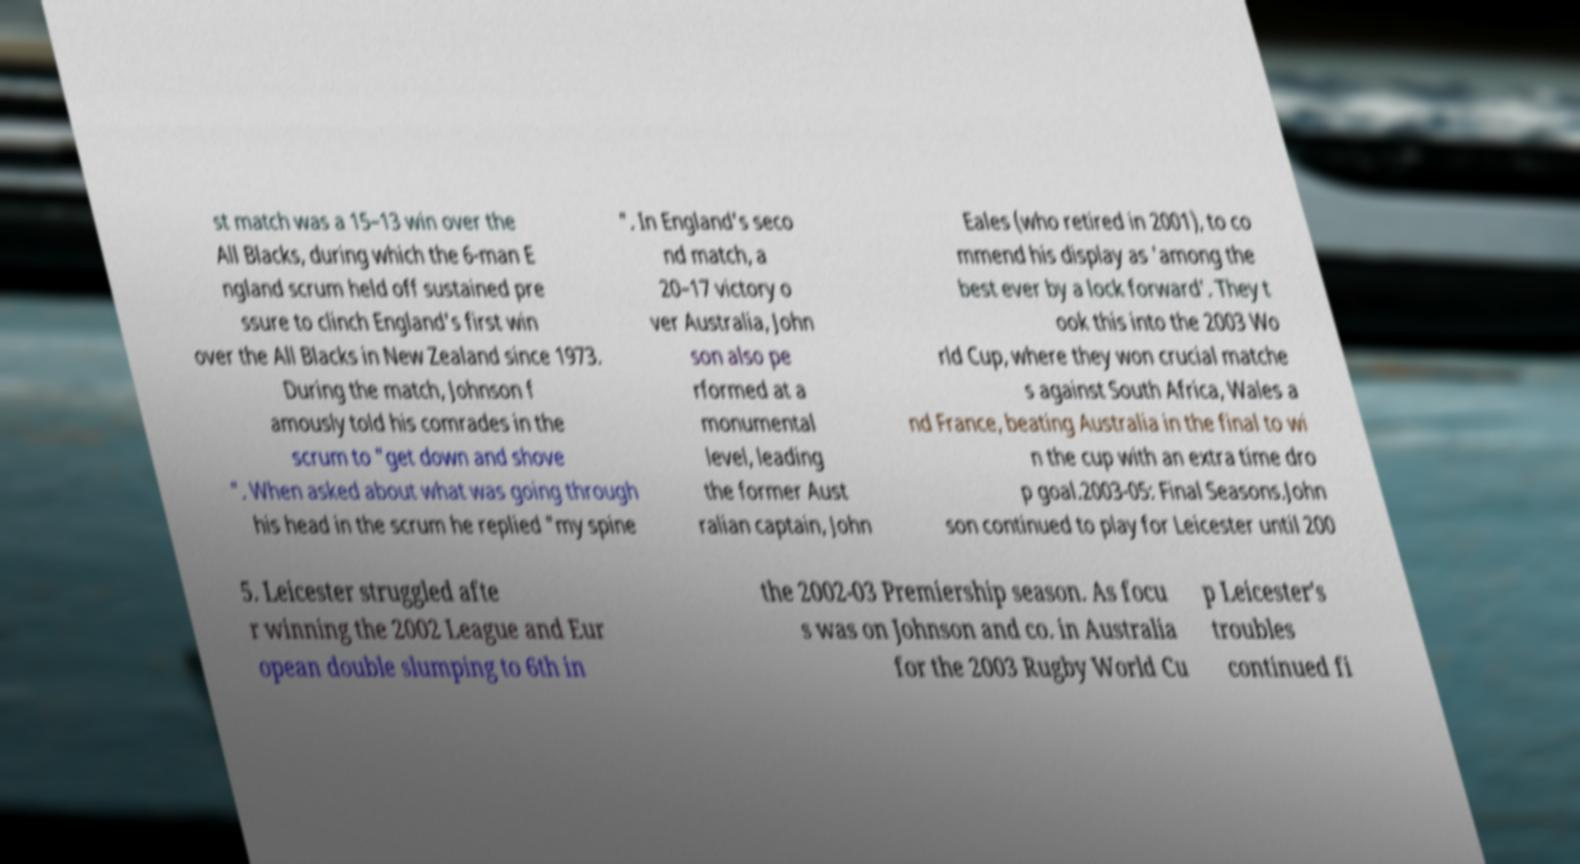What messages or text are displayed in this image? I need them in a readable, typed format. st match was a 15–13 win over the All Blacks, during which the 6-man E ngland scrum held off sustained pre ssure to clinch England's first win over the All Blacks in New Zealand since 1973. During the match, Johnson f amously told his comrades in the scrum to "get down and shove ". When asked about what was going through his head in the scrum he replied "my spine ". In England's seco nd match, a 20–17 victory o ver Australia, John son also pe rformed at a monumental level, leading the former Aust ralian captain, John Eales (who retired in 2001), to co mmend his display as 'among the best ever by a lock forward'. They t ook this into the 2003 Wo rld Cup, where they won crucial matche s against South Africa, Wales a nd France, beating Australia in the final to wi n the cup with an extra time dro p goal.2003-05: Final Seasons.John son continued to play for Leicester until 200 5. Leicester struggled afte r winning the 2002 League and Eur opean double slumping to 6th in the 2002-03 Premiership season. As focu s was on Johnson and co. in Australia for the 2003 Rugby World Cu p Leicester's troubles continued fi 